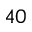Convert formula to latex. <formula><loc_0><loc_0><loc_500><loc_500>4 0</formula> 